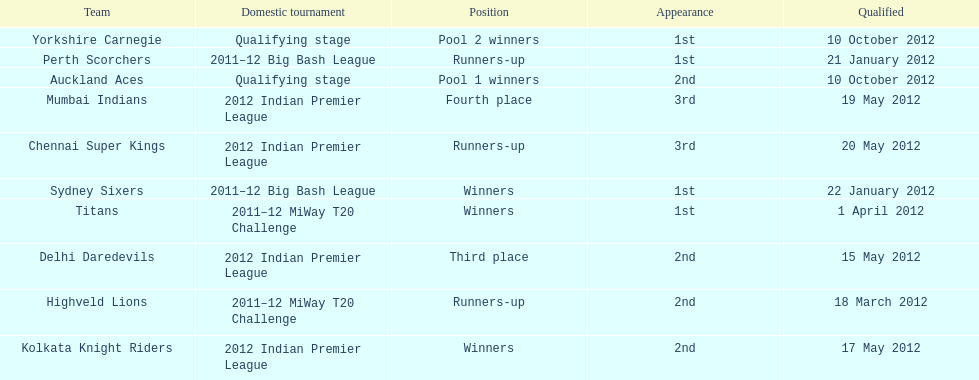What is the total number of teams? 10. 